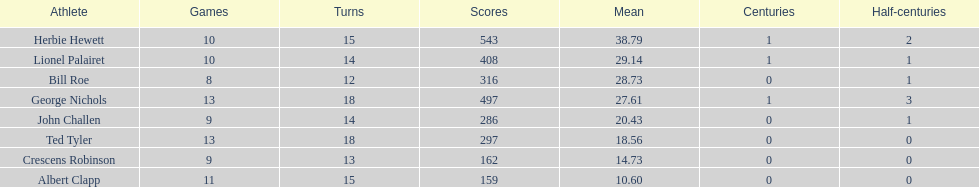How many runs did ted tyler have? 297. 